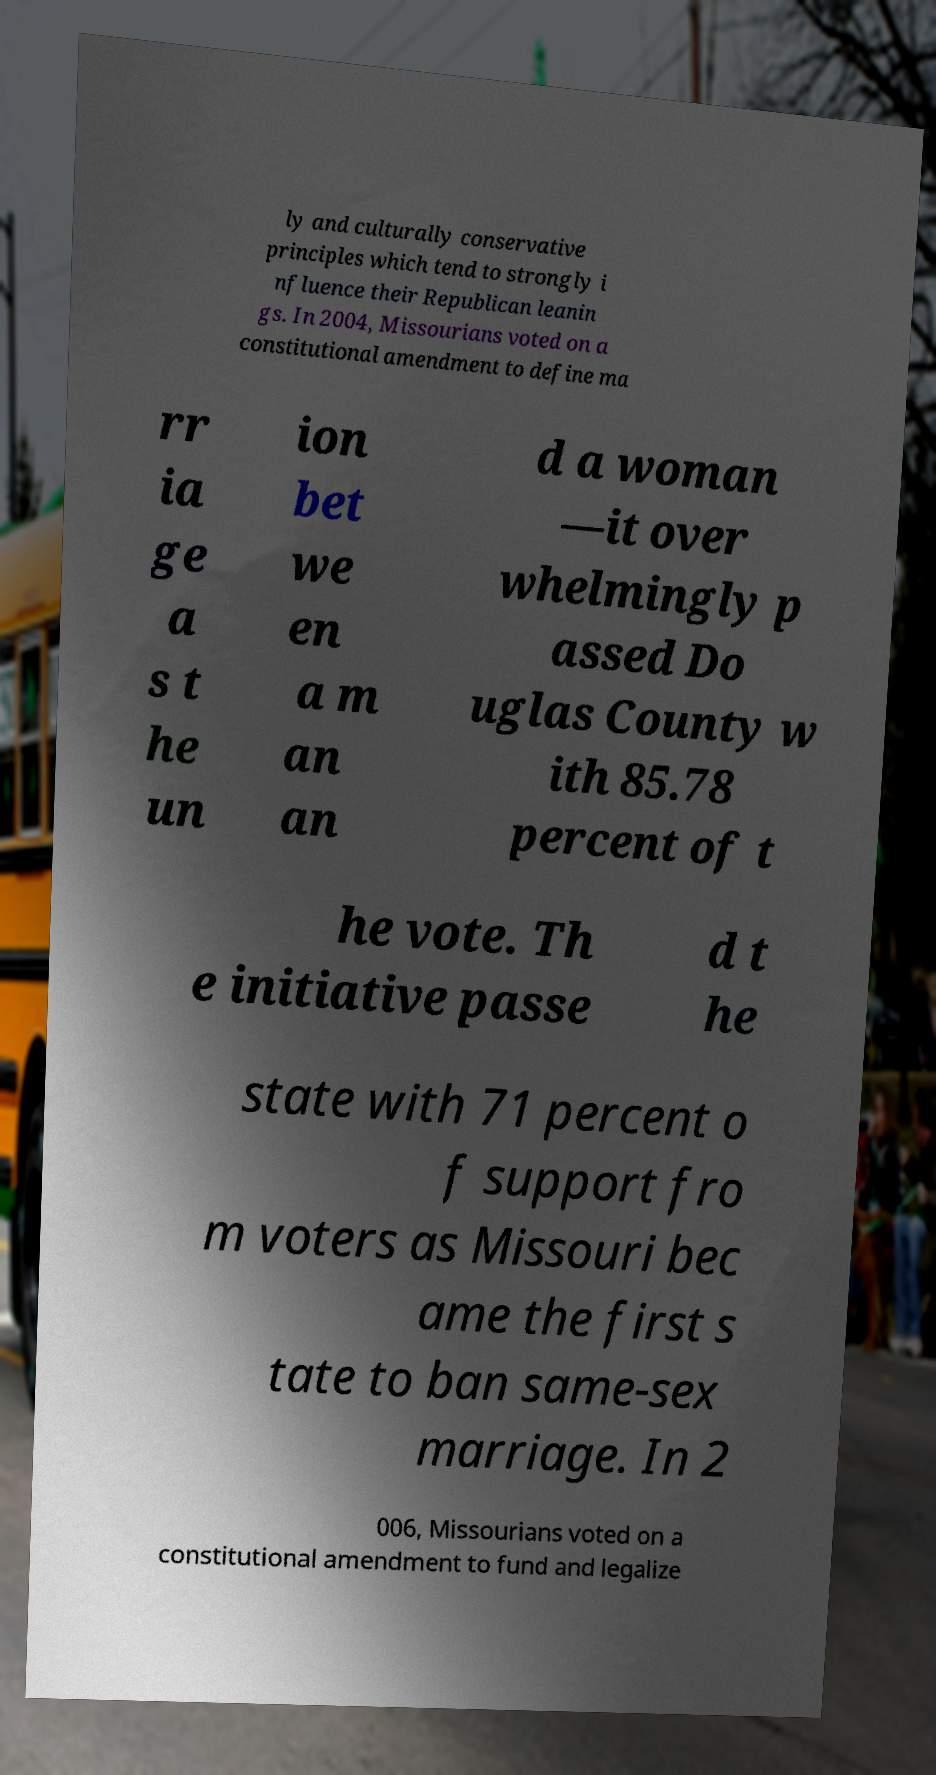Could you extract and type out the text from this image? ly and culturally conservative principles which tend to strongly i nfluence their Republican leanin gs. In 2004, Missourians voted on a constitutional amendment to define ma rr ia ge a s t he un ion bet we en a m an an d a woman —it over whelmingly p assed Do uglas County w ith 85.78 percent of t he vote. Th e initiative passe d t he state with 71 percent o f support fro m voters as Missouri bec ame the first s tate to ban same-sex marriage. In 2 006, Missourians voted on a constitutional amendment to fund and legalize 